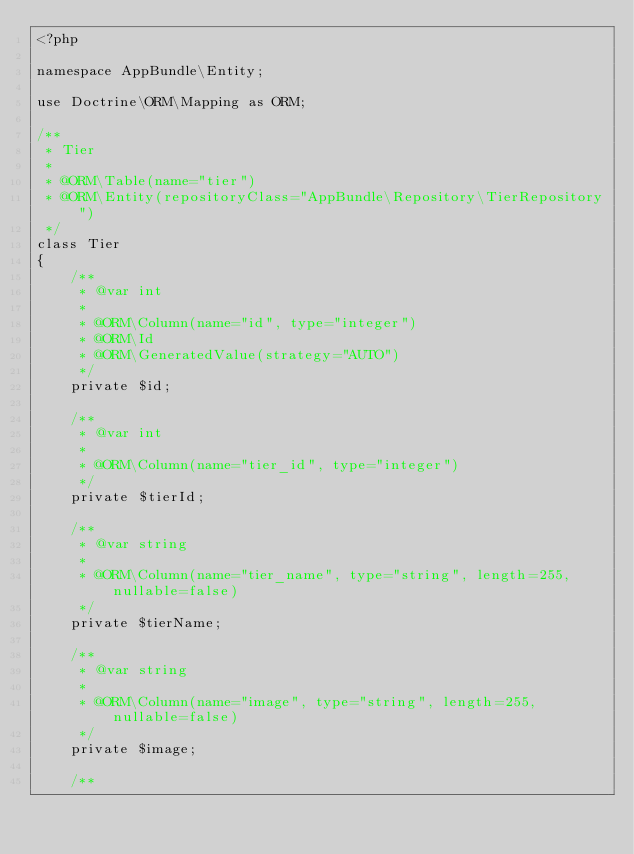Convert code to text. <code><loc_0><loc_0><loc_500><loc_500><_PHP_><?php

namespace AppBundle\Entity;

use Doctrine\ORM\Mapping as ORM;

/**
 * Tier
 *
 * @ORM\Table(name="tier")
 * @ORM\Entity(repositoryClass="AppBundle\Repository\TierRepository")
 */
class Tier
{
    /**
     * @var int
     *
     * @ORM\Column(name="id", type="integer")
     * @ORM\Id
     * @ORM\GeneratedValue(strategy="AUTO")
     */
    private $id;

    /**
     * @var int
     *
     * @ORM\Column(name="tier_id", type="integer")
     */
    private $tierId;

    /**
     * @var string
     *
     * @ORM\Column(name="tier_name", type="string", length=255, nullable=false)
     */
    private $tierName;

    /**
     * @var string
     *
     * @ORM\Column(name="image", type="string", length=255, nullable=false)
     */
    private $image;

    /**</code> 